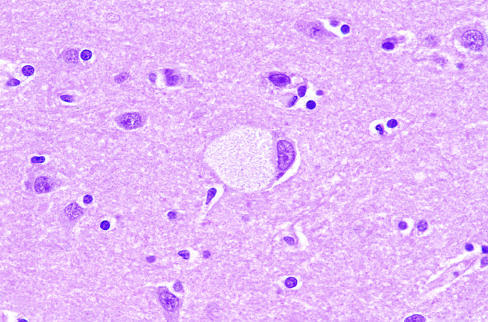what has obvious lipid vacuolation under the light microscope?
Answer the question using a single word or phrase. A large neuron 